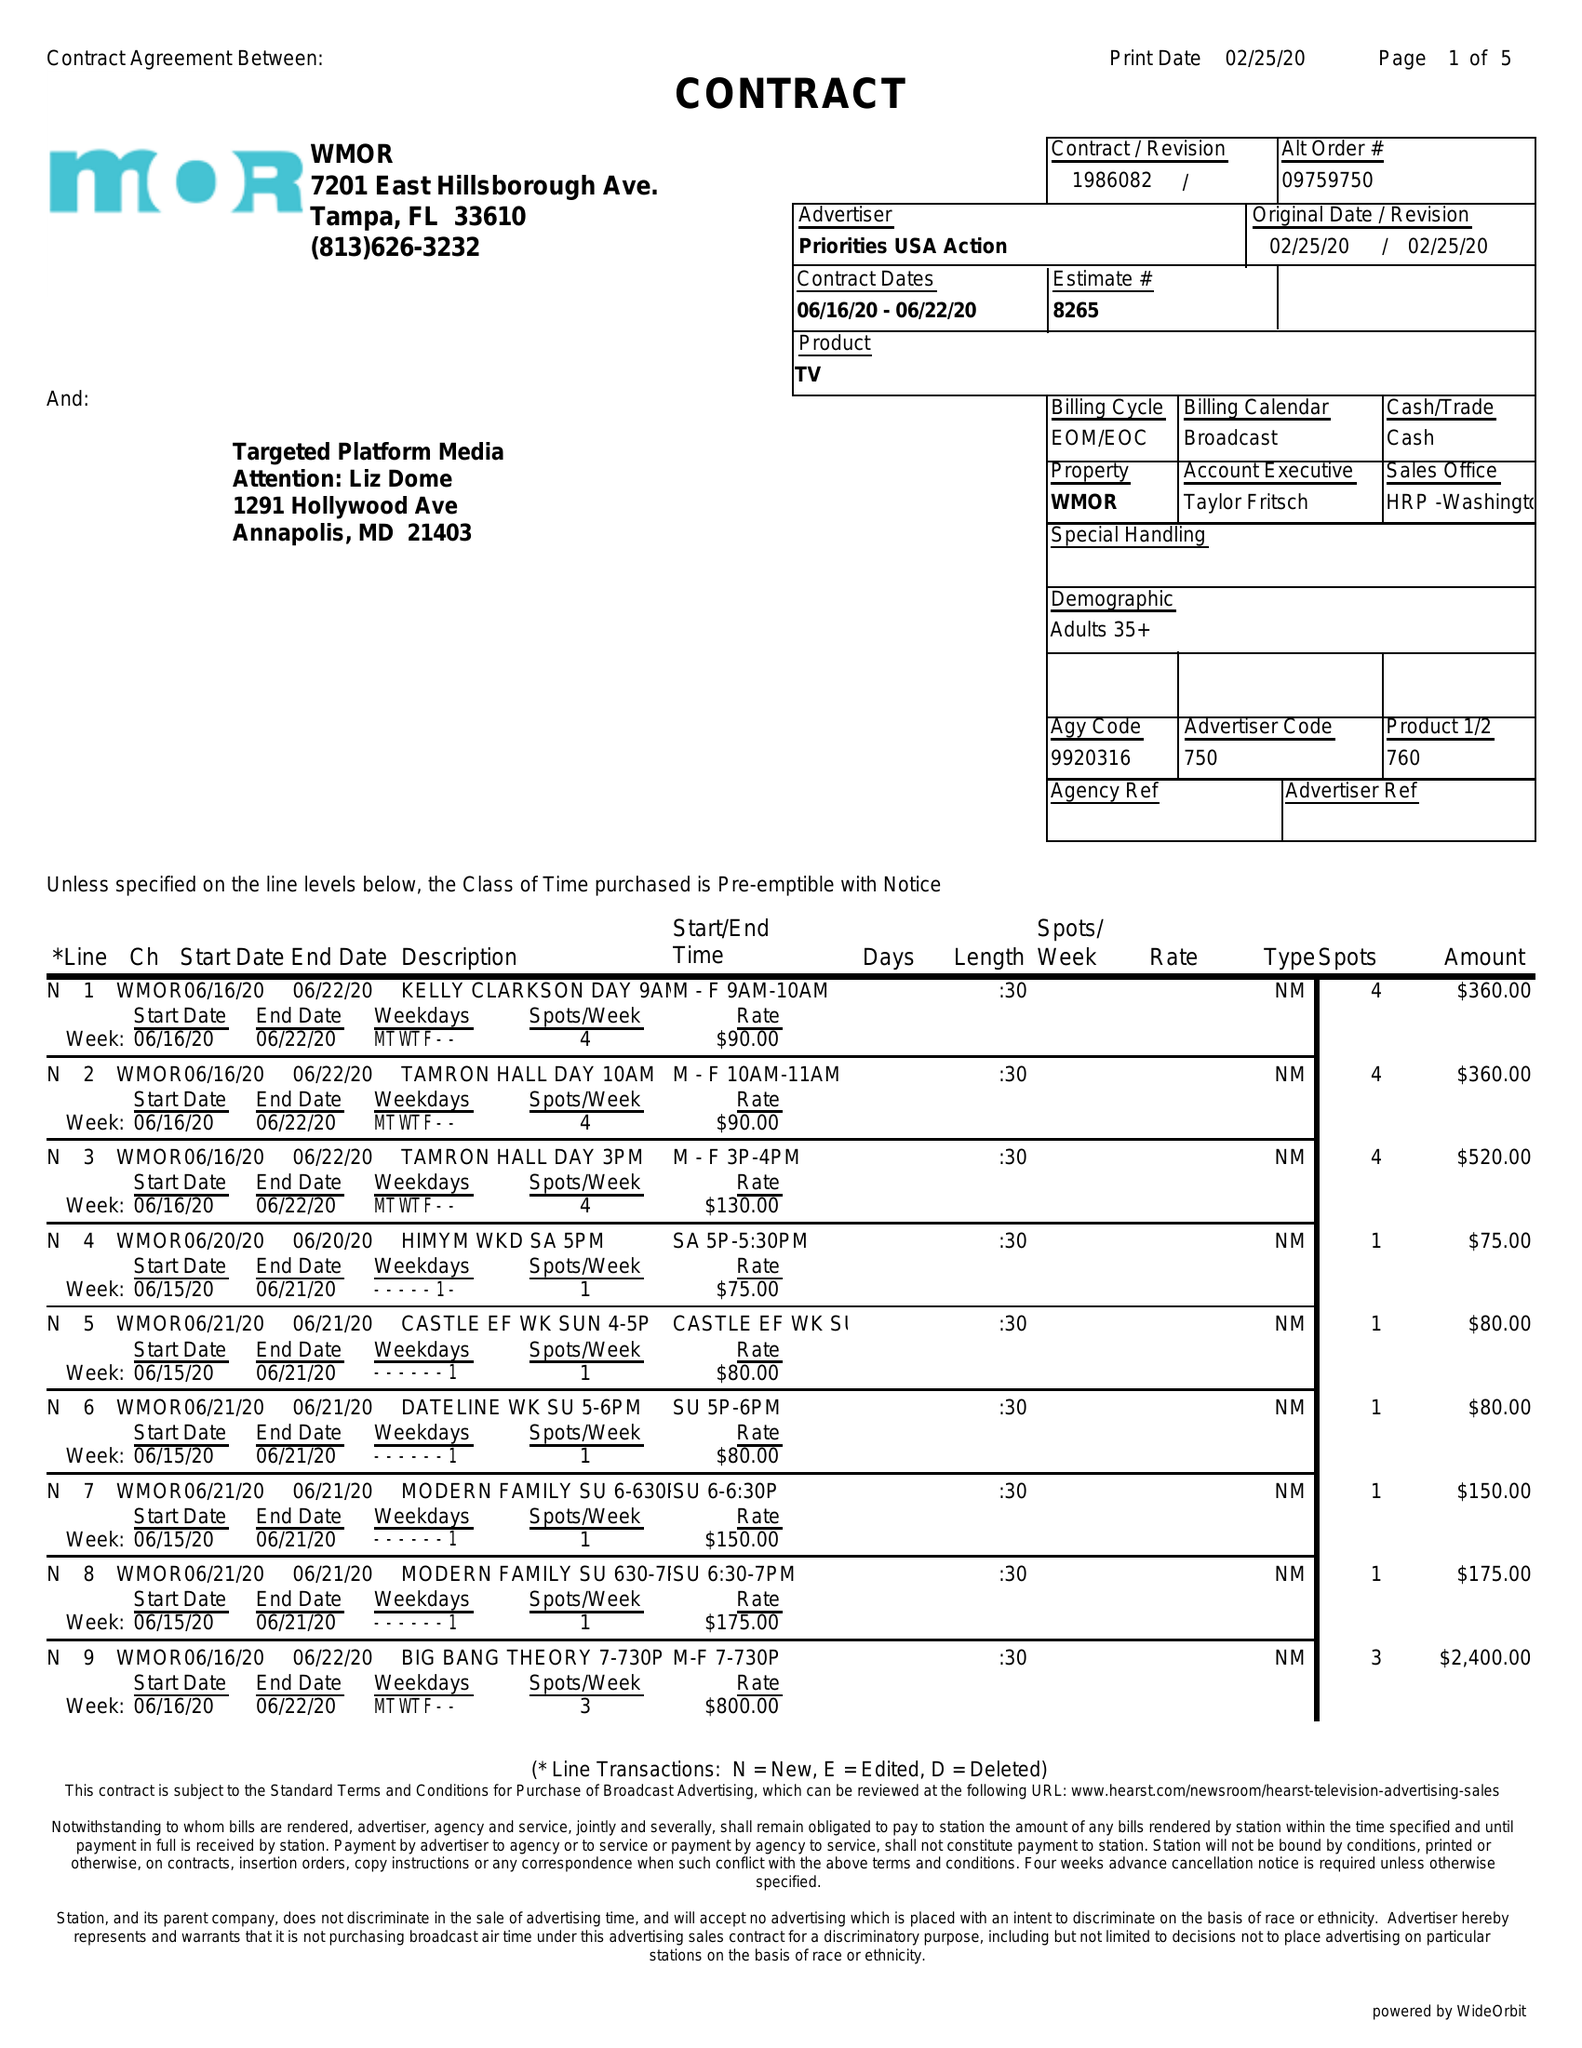What is the value for the flight_from?
Answer the question using a single word or phrase. 06/16/20 